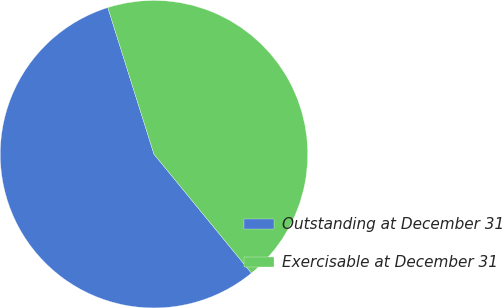Convert chart. <chart><loc_0><loc_0><loc_500><loc_500><pie_chart><fcel>Outstanding at December 31<fcel>Exercisable at December 31<nl><fcel>56.07%<fcel>43.93%<nl></chart> 